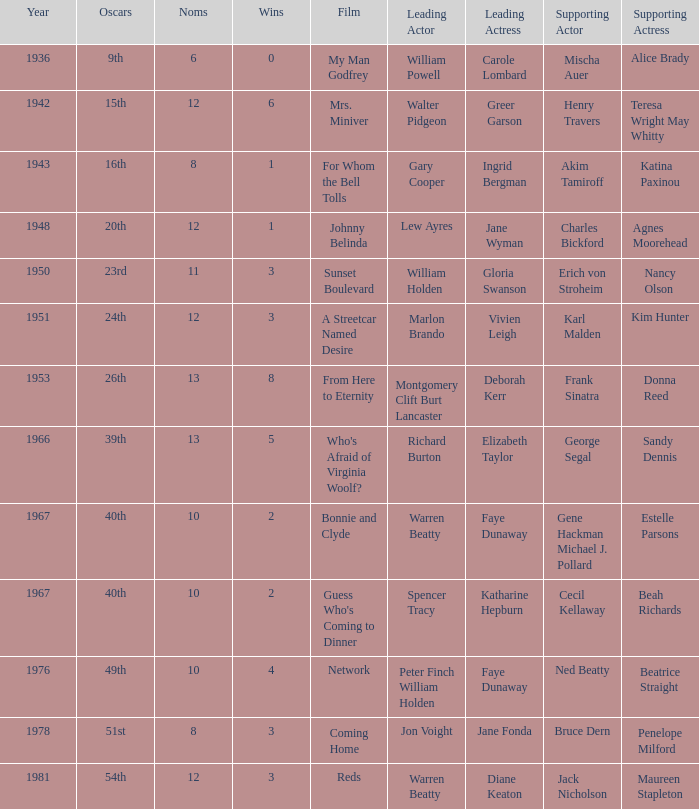Who was the leading actress in a film with Warren Beatty as the leading actor and also at the 40th Oscars? Faye Dunaway. 